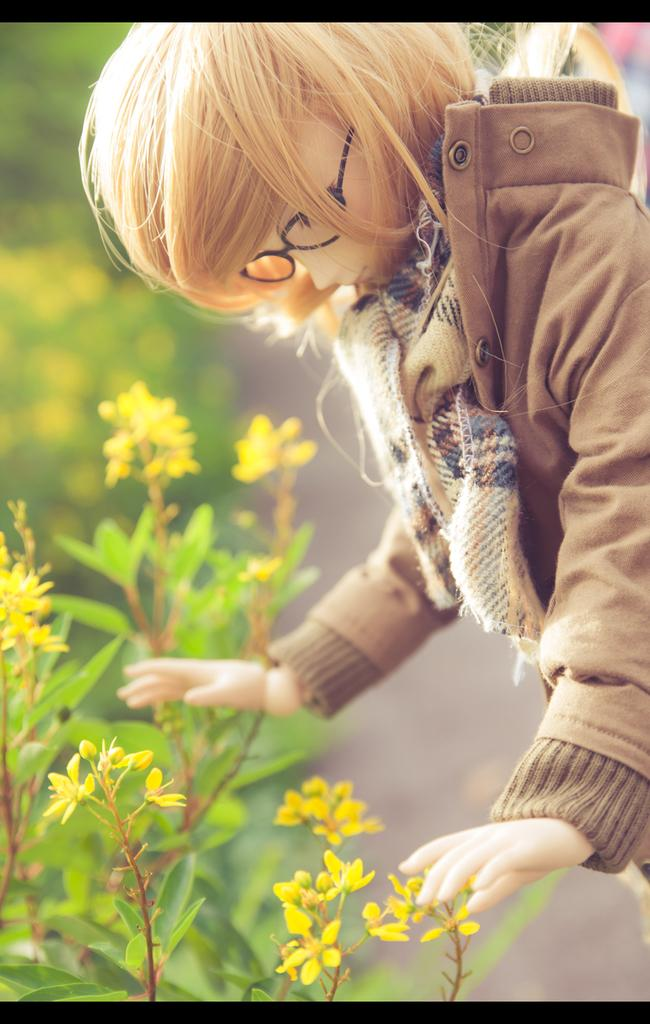What object is present in the image that is typically associated with vision? There is a pair of spectacles in the image. What type of decorative items can be seen in the image? There are flowers in the image. What can be seen in the background of the image? There are plants visible in the background of the image. How would you describe the background of the image? The background of the image is blurry. What type of knife is being used to sing songs in the image? There is no knife or singing in the image; it features a doll, spectacles, flowers, and a blurry background. 